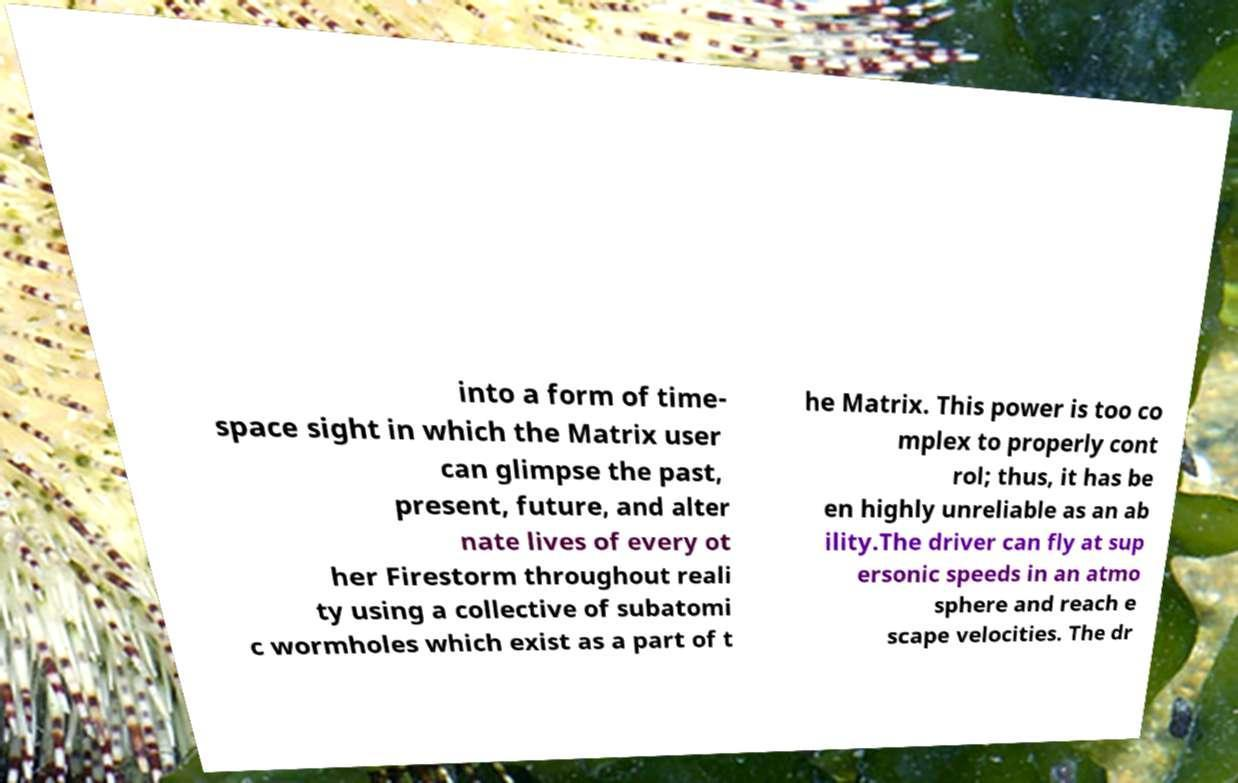For documentation purposes, I need the text within this image transcribed. Could you provide that? into a form of time- space sight in which the Matrix user can glimpse the past, present, future, and alter nate lives of every ot her Firestorm throughout reali ty using a collective of subatomi c wormholes which exist as a part of t he Matrix. This power is too co mplex to properly cont rol; thus, it has be en highly unreliable as an ab ility.The driver can fly at sup ersonic speeds in an atmo sphere and reach e scape velocities. The dr 